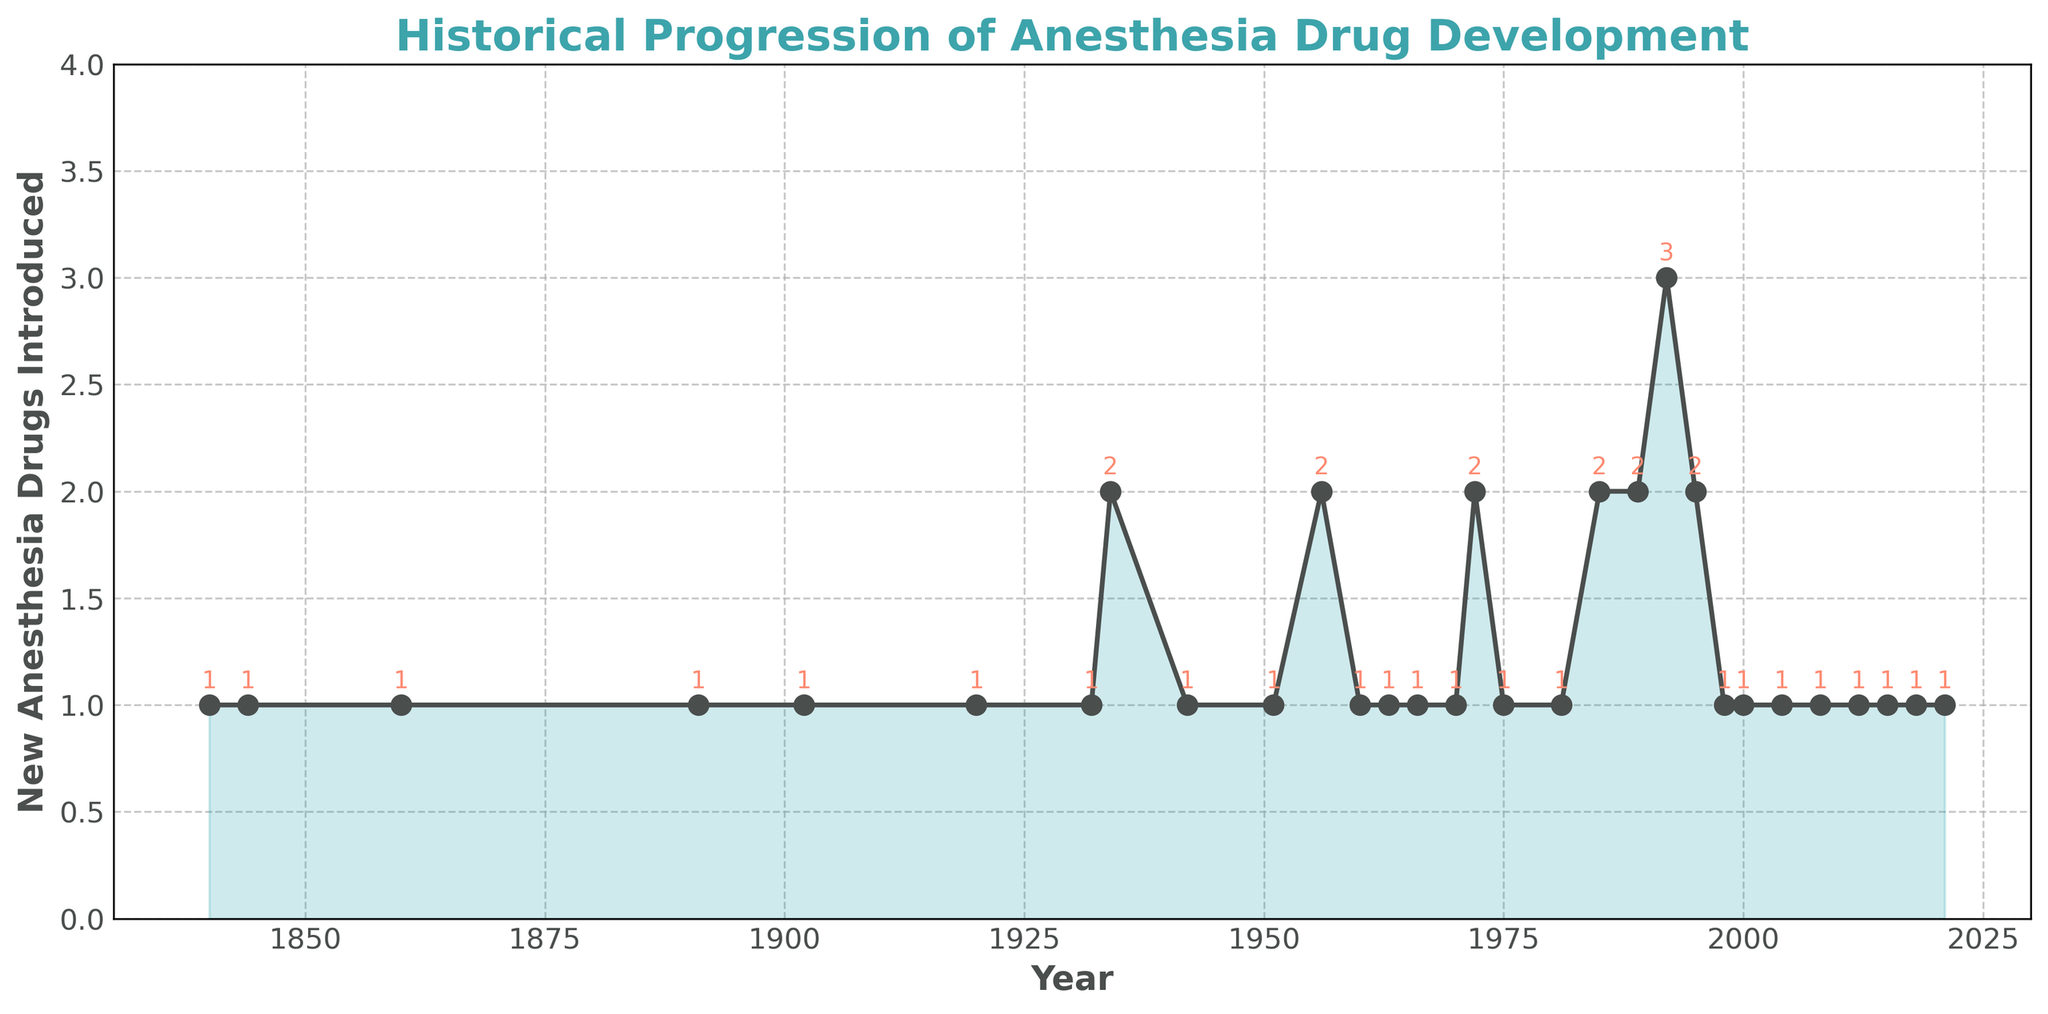Which year introduced the most new anesthesia drugs? The year with the highest peak on the line chart represents the year with the most new drugs introduced. By inspecting the chart, 1992 has the highest peak with 3 new drugs introduced.
Answer: 1992 How many years introduced exactly 2 new anesthesia drugs? Count the data points where the number of new drugs introduced equals 2. These years are 1934, 1956, 1972, 1985, 1989, and 1995. There are 6 such years.
Answer: 6 What is the difference between the total number of new anesthesia drugs introduced in the 20th century (1901-2000) and the 21st century (2001-2021)? First, sum the number of new drugs introduced in the 20th century (1+1+2+1+2+1+1+1+2+3+2+1 = 18). Then sum the number of new drugs introduced in the 21st century (1+1+1+1+1 = 5). The difference is 18 - 5 = 13.
Answer: 13 What visual attributes signify the years with the highest number of new anesthesia drugs introduced? The chart has peaks marked with circles, and the filled area under the line is highest at these points. The annotated number at the peak is 3.
Answer: Peaks and annotations 